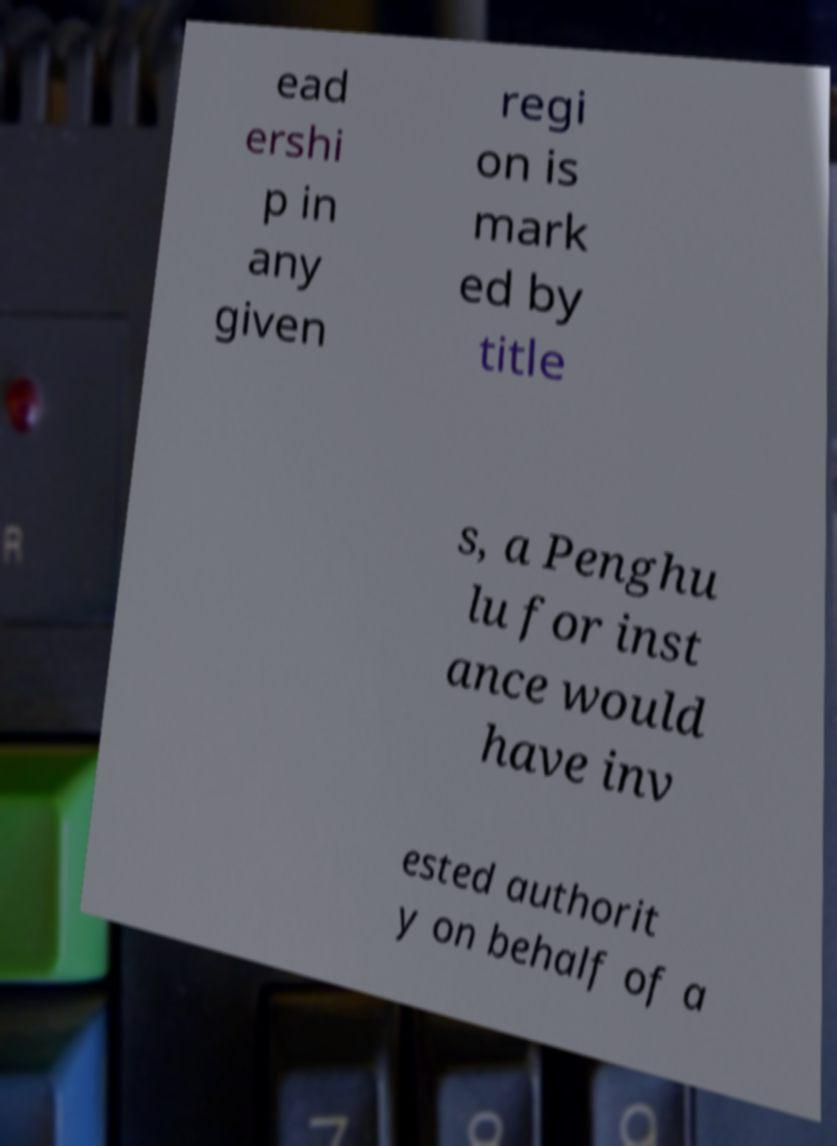Can you read and provide the text displayed in the image?This photo seems to have some interesting text. Can you extract and type it out for me? ead ershi p in any given regi on is mark ed by title s, a Penghu lu for inst ance would have inv ested authorit y on behalf of a 